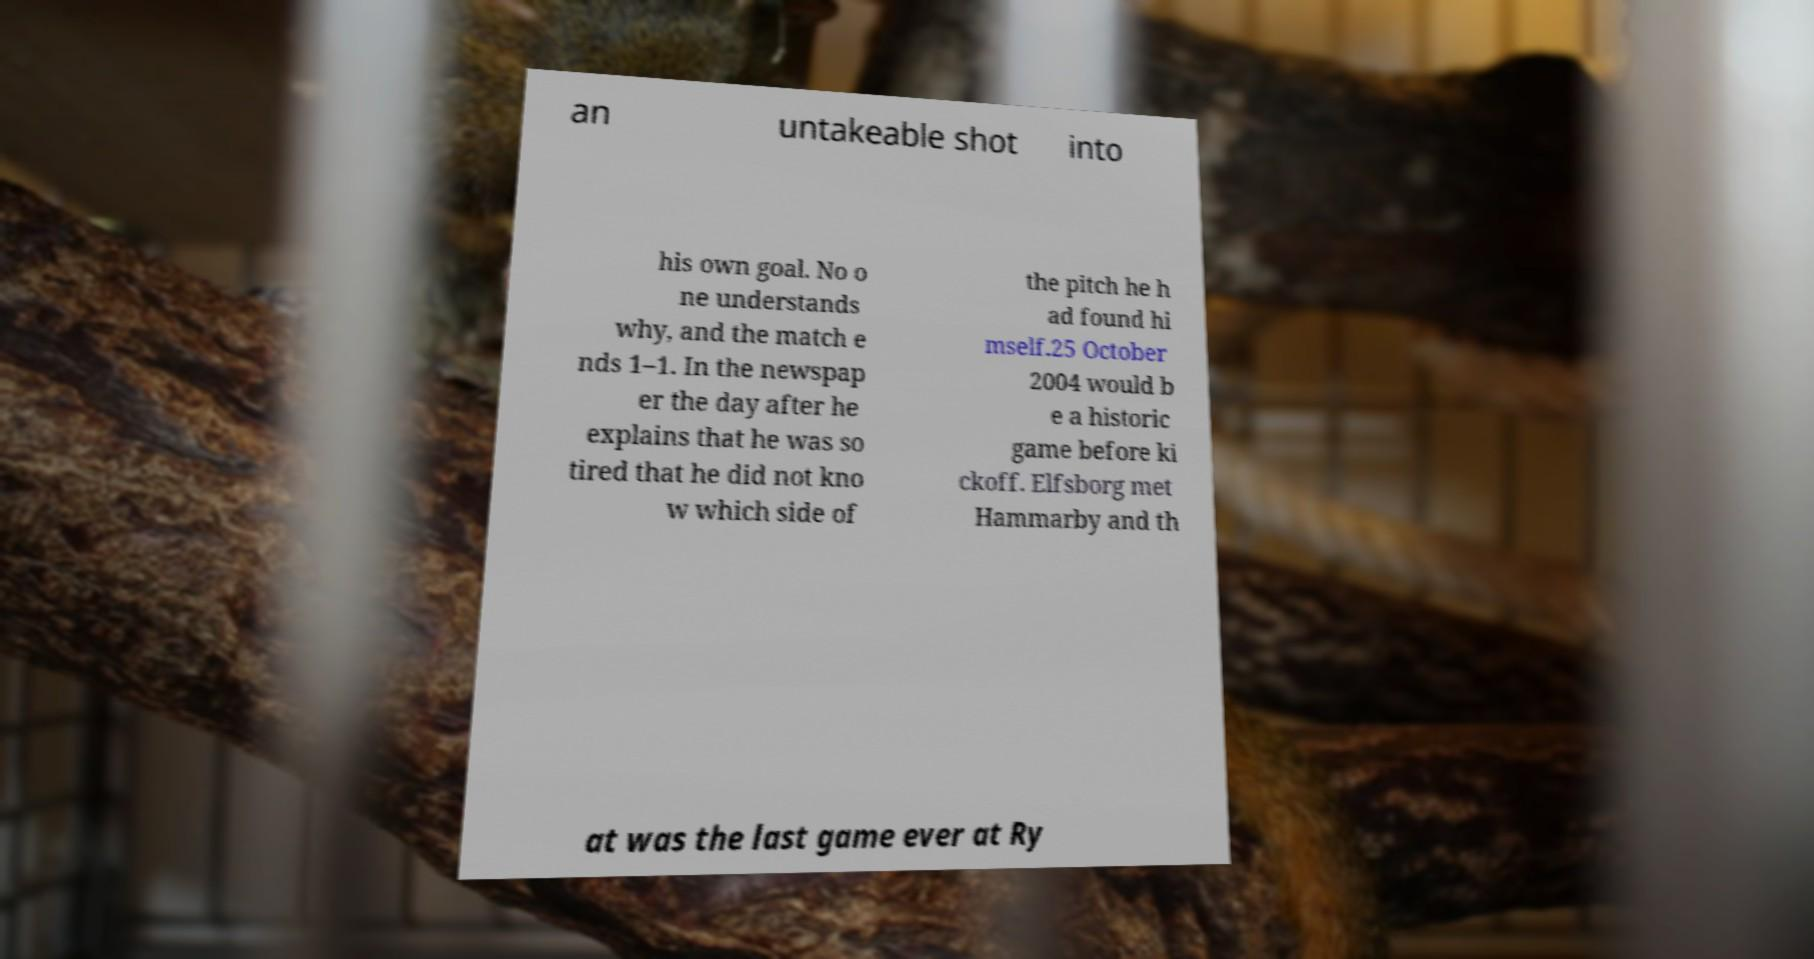Could you extract and type out the text from this image? an untakeable shot into his own goal. No o ne understands why, and the match e nds 1–1. In the newspap er the day after he explains that he was so tired that he did not kno w which side of the pitch he h ad found hi mself.25 October 2004 would b e a historic game before ki ckoff. Elfsborg met Hammarby and th at was the last game ever at Ry 